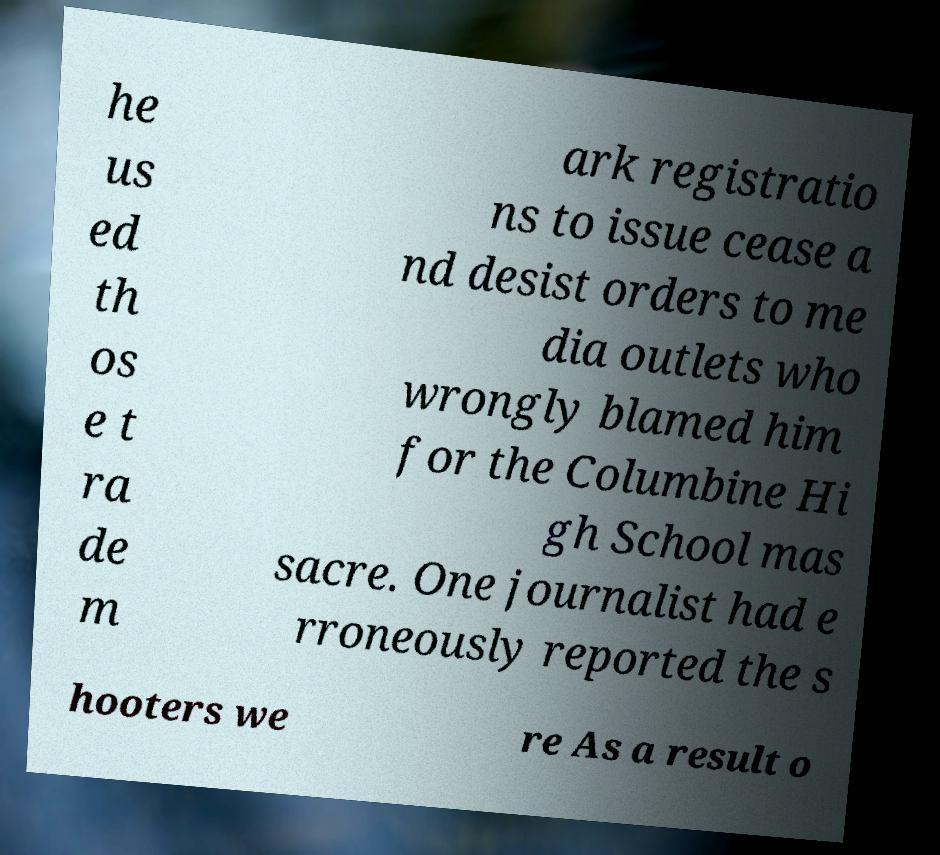What messages or text are displayed in this image? I need them in a readable, typed format. he us ed th os e t ra de m ark registratio ns to issue cease a nd desist orders to me dia outlets who wrongly blamed him for the Columbine Hi gh School mas sacre. One journalist had e rroneously reported the s hooters we re As a result o 